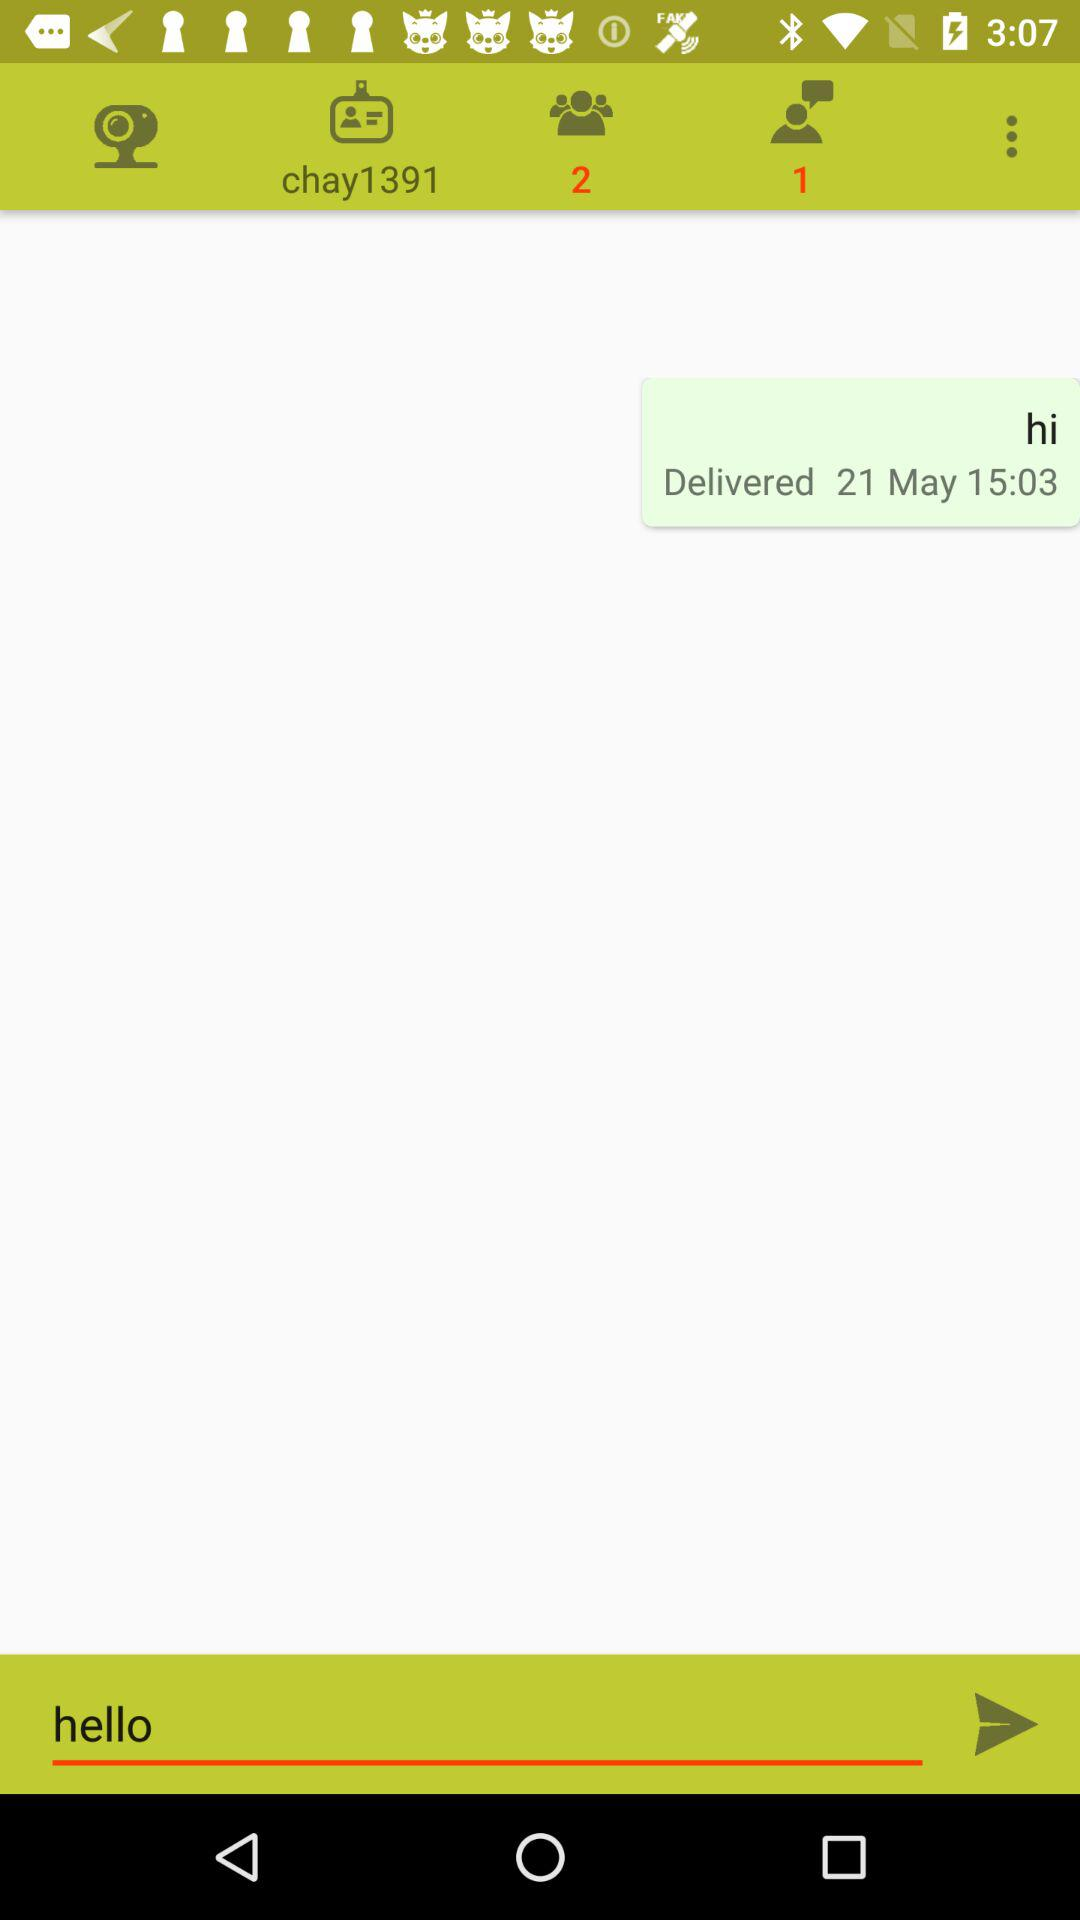What could be the reason that the message is still unread? There could be several reasons why the message remains unread. The recipient might be busy, have their phone on silent or not with them, or they may have seen the notification but chosen to respond later. There's also a possibility that they intentionally ignored the message, or they saw the message preview and did not open the conversation to mark it as read. 